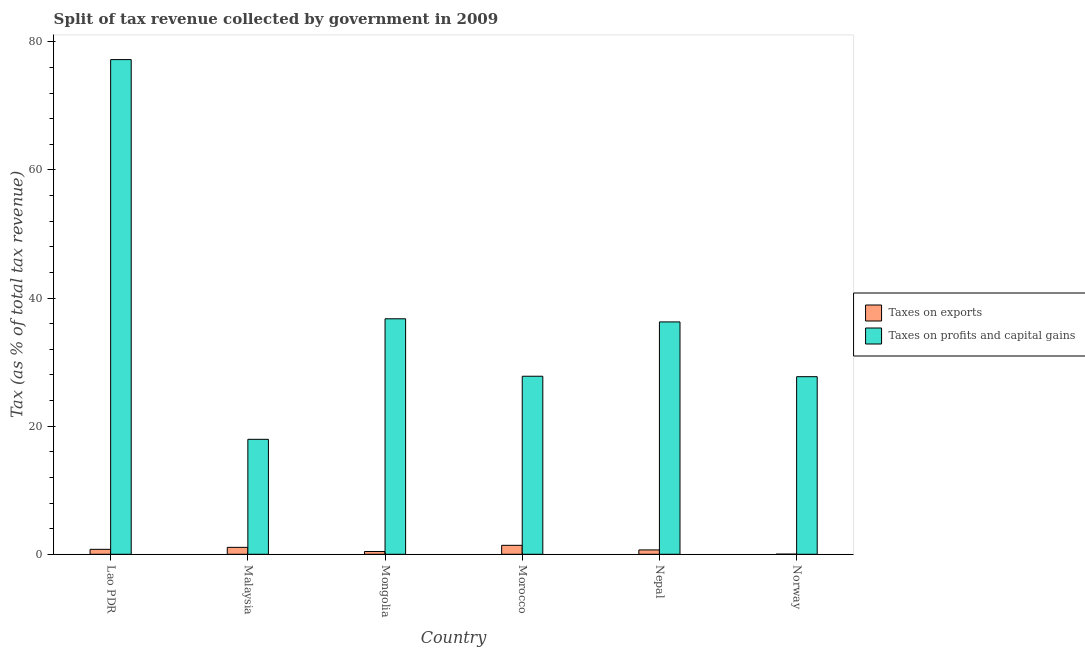How many groups of bars are there?
Your answer should be compact. 6. Are the number of bars on each tick of the X-axis equal?
Keep it short and to the point. Yes. How many bars are there on the 5th tick from the left?
Offer a terse response. 2. In how many cases, is the number of bars for a given country not equal to the number of legend labels?
Your answer should be compact. 0. What is the percentage of revenue obtained from taxes on profits and capital gains in Norway?
Keep it short and to the point. 27.72. Across all countries, what is the maximum percentage of revenue obtained from taxes on exports?
Offer a terse response. 1.4. Across all countries, what is the minimum percentage of revenue obtained from taxes on exports?
Your answer should be compact. 0.02. In which country was the percentage of revenue obtained from taxes on profits and capital gains maximum?
Offer a terse response. Lao PDR. In which country was the percentage of revenue obtained from taxes on profits and capital gains minimum?
Make the answer very short. Malaysia. What is the total percentage of revenue obtained from taxes on profits and capital gains in the graph?
Your response must be concise. 223.72. What is the difference between the percentage of revenue obtained from taxes on exports in Mongolia and that in Morocco?
Give a very brief answer. -0.96. What is the difference between the percentage of revenue obtained from taxes on profits and capital gains in Norway and the percentage of revenue obtained from taxes on exports in Mongolia?
Make the answer very short. 27.29. What is the average percentage of revenue obtained from taxes on profits and capital gains per country?
Offer a terse response. 37.29. What is the difference between the percentage of revenue obtained from taxes on profits and capital gains and percentage of revenue obtained from taxes on exports in Nepal?
Provide a succinct answer. 35.6. What is the ratio of the percentage of revenue obtained from taxes on profits and capital gains in Lao PDR to that in Morocco?
Make the answer very short. 2.78. What is the difference between the highest and the second highest percentage of revenue obtained from taxes on profits and capital gains?
Your answer should be compact. 40.46. What is the difference between the highest and the lowest percentage of revenue obtained from taxes on exports?
Your response must be concise. 1.38. In how many countries, is the percentage of revenue obtained from taxes on exports greater than the average percentage of revenue obtained from taxes on exports taken over all countries?
Offer a very short reply. 3. What does the 1st bar from the left in Malaysia represents?
Offer a terse response. Taxes on exports. What does the 1st bar from the right in Norway represents?
Your answer should be compact. Taxes on profits and capital gains. How many countries are there in the graph?
Ensure brevity in your answer.  6. Does the graph contain grids?
Provide a short and direct response. No. Where does the legend appear in the graph?
Provide a short and direct response. Center right. What is the title of the graph?
Offer a very short reply. Split of tax revenue collected by government in 2009. Does "Net savings(excluding particulate emission damage)" appear as one of the legend labels in the graph?
Provide a short and direct response. No. What is the label or title of the X-axis?
Your answer should be compact. Country. What is the label or title of the Y-axis?
Make the answer very short. Tax (as % of total tax revenue). What is the Tax (as % of total tax revenue) of Taxes on exports in Lao PDR?
Your response must be concise. 0.77. What is the Tax (as % of total tax revenue) in Taxes on profits and capital gains in Lao PDR?
Your answer should be compact. 77.22. What is the Tax (as % of total tax revenue) in Taxes on exports in Malaysia?
Offer a terse response. 1.08. What is the Tax (as % of total tax revenue) in Taxes on profits and capital gains in Malaysia?
Provide a short and direct response. 17.95. What is the Tax (as % of total tax revenue) in Taxes on exports in Mongolia?
Make the answer very short. 0.44. What is the Tax (as % of total tax revenue) in Taxes on profits and capital gains in Mongolia?
Give a very brief answer. 36.76. What is the Tax (as % of total tax revenue) in Taxes on exports in Morocco?
Give a very brief answer. 1.4. What is the Tax (as % of total tax revenue) of Taxes on profits and capital gains in Morocco?
Keep it short and to the point. 27.79. What is the Tax (as % of total tax revenue) of Taxes on exports in Nepal?
Give a very brief answer. 0.68. What is the Tax (as % of total tax revenue) of Taxes on profits and capital gains in Nepal?
Your response must be concise. 36.27. What is the Tax (as % of total tax revenue) in Taxes on exports in Norway?
Your answer should be compact. 0.02. What is the Tax (as % of total tax revenue) in Taxes on profits and capital gains in Norway?
Give a very brief answer. 27.72. Across all countries, what is the maximum Tax (as % of total tax revenue) in Taxes on exports?
Keep it short and to the point. 1.4. Across all countries, what is the maximum Tax (as % of total tax revenue) in Taxes on profits and capital gains?
Offer a terse response. 77.22. Across all countries, what is the minimum Tax (as % of total tax revenue) in Taxes on exports?
Offer a very short reply. 0.02. Across all countries, what is the minimum Tax (as % of total tax revenue) of Taxes on profits and capital gains?
Provide a succinct answer. 17.95. What is the total Tax (as % of total tax revenue) of Taxes on exports in the graph?
Give a very brief answer. 4.39. What is the total Tax (as % of total tax revenue) of Taxes on profits and capital gains in the graph?
Make the answer very short. 223.72. What is the difference between the Tax (as % of total tax revenue) in Taxes on exports in Lao PDR and that in Malaysia?
Ensure brevity in your answer.  -0.31. What is the difference between the Tax (as % of total tax revenue) in Taxes on profits and capital gains in Lao PDR and that in Malaysia?
Ensure brevity in your answer.  59.28. What is the difference between the Tax (as % of total tax revenue) in Taxes on exports in Lao PDR and that in Mongolia?
Offer a very short reply. 0.33. What is the difference between the Tax (as % of total tax revenue) of Taxes on profits and capital gains in Lao PDR and that in Mongolia?
Make the answer very short. 40.46. What is the difference between the Tax (as % of total tax revenue) in Taxes on exports in Lao PDR and that in Morocco?
Keep it short and to the point. -0.63. What is the difference between the Tax (as % of total tax revenue) in Taxes on profits and capital gains in Lao PDR and that in Morocco?
Your answer should be very brief. 49.43. What is the difference between the Tax (as % of total tax revenue) of Taxes on exports in Lao PDR and that in Nepal?
Offer a very short reply. 0.09. What is the difference between the Tax (as % of total tax revenue) of Taxes on profits and capital gains in Lao PDR and that in Nepal?
Your answer should be very brief. 40.95. What is the difference between the Tax (as % of total tax revenue) in Taxes on exports in Lao PDR and that in Norway?
Ensure brevity in your answer.  0.75. What is the difference between the Tax (as % of total tax revenue) of Taxes on profits and capital gains in Lao PDR and that in Norway?
Offer a terse response. 49.5. What is the difference between the Tax (as % of total tax revenue) of Taxes on exports in Malaysia and that in Mongolia?
Ensure brevity in your answer.  0.65. What is the difference between the Tax (as % of total tax revenue) in Taxes on profits and capital gains in Malaysia and that in Mongolia?
Give a very brief answer. -18.82. What is the difference between the Tax (as % of total tax revenue) in Taxes on exports in Malaysia and that in Morocco?
Give a very brief answer. -0.32. What is the difference between the Tax (as % of total tax revenue) of Taxes on profits and capital gains in Malaysia and that in Morocco?
Your answer should be compact. -9.85. What is the difference between the Tax (as % of total tax revenue) in Taxes on exports in Malaysia and that in Nepal?
Offer a terse response. 0.4. What is the difference between the Tax (as % of total tax revenue) of Taxes on profits and capital gains in Malaysia and that in Nepal?
Offer a very short reply. -18.33. What is the difference between the Tax (as % of total tax revenue) in Taxes on exports in Malaysia and that in Norway?
Offer a terse response. 1.06. What is the difference between the Tax (as % of total tax revenue) in Taxes on profits and capital gains in Malaysia and that in Norway?
Give a very brief answer. -9.78. What is the difference between the Tax (as % of total tax revenue) in Taxes on exports in Mongolia and that in Morocco?
Provide a short and direct response. -0.96. What is the difference between the Tax (as % of total tax revenue) in Taxes on profits and capital gains in Mongolia and that in Morocco?
Your answer should be very brief. 8.97. What is the difference between the Tax (as % of total tax revenue) in Taxes on exports in Mongolia and that in Nepal?
Keep it short and to the point. -0.24. What is the difference between the Tax (as % of total tax revenue) in Taxes on profits and capital gains in Mongolia and that in Nepal?
Keep it short and to the point. 0.49. What is the difference between the Tax (as % of total tax revenue) in Taxes on exports in Mongolia and that in Norway?
Your answer should be compact. 0.42. What is the difference between the Tax (as % of total tax revenue) in Taxes on profits and capital gains in Mongolia and that in Norway?
Make the answer very short. 9.04. What is the difference between the Tax (as % of total tax revenue) of Taxes on exports in Morocco and that in Nepal?
Make the answer very short. 0.72. What is the difference between the Tax (as % of total tax revenue) in Taxes on profits and capital gains in Morocco and that in Nepal?
Offer a very short reply. -8.48. What is the difference between the Tax (as % of total tax revenue) in Taxes on exports in Morocco and that in Norway?
Offer a very short reply. 1.38. What is the difference between the Tax (as % of total tax revenue) of Taxes on profits and capital gains in Morocco and that in Norway?
Make the answer very short. 0.07. What is the difference between the Tax (as % of total tax revenue) of Taxes on exports in Nepal and that in Norway?
Give a very brief answer. 0.66. What is the difference between the Tax (as % of total tax revenue) in Taxes on profits and capital gains in Nepal and that in Norway?
Keep it short and to the point. 8.55. What is the difference between the Tax (as % of total tax revenue) in Taxes on exports in Lao PDR and the Tax (as % of total tax revenue) in Taxes on profits and capital gains in Malaysia?
Ensure brevity in your answer.  -17.17. What is the difference between the Tax (as % of total tax revenue) in Taxes on exports in Lao PDR and the Tax (as % of total tax revenue) in Taxes on profits and capital gains in Mongolia?
Your answer should be very brief. -35.99. What is the difference between the Tax (as % of total tax revenue) in Taxes on exports in Lao PDR and the Tax (as % of total tax revenue) in Taxes on profits and capital gains in Morocco?
Keep it short and to the point. -27.02. What is the difference between the Tax (as % of total tax revenue) in Taxes on exports in Lao PDR and the Tax (as % of total tax revenue) in Taxes on profits and capital gains in Nepal?
Your answer should be compact. -35.5. What is the difference between the Tax (as % of total tax revenue) of Taxes on exports in Lao PDR and the Tax (as % of total tax revenue) of Taxes on profits and capital gains in Norway?
Provide a short and direct response. -26.95. What is the difference between the Tax (as % of total tax revenue) of Taxes on exports in Malaysia and the Tax (as % of total tax revenue) of Taxes on profits and capital gains in Mongolia?
Offer a very short reply. -35.68. What is the difference between the Tax (as % of total tax revenue) of Taxes on exports in Malaysia and the Tax (as % of total tax revenue) of Taxes on profits and capital gains in Morocco?
Provide a succinct answer. -26.71. What is the difference between the Tax (as % of total tax revenue) of Taxes on exports in Malaysia and the Tax (as % of total tax revenue) of Taxes on profits and capital gains in Nepal?
Make the answer very short. -35.19. What is the difference between the Tax (as % of total tax revenue) in Taxes on exports in Malaysia and the Tax (as % of total tax revenue) in Taxes on profits and capital gains in Norway?
Your answer should be compact. -26.64. What is the difference between the Tax (as % of total tax revenue) in Taxes on exports in Mongolia and the Tax (as % of total tax revenue) in Taxes on profits and capital gains in Morocco?
Your answer should be compact. -27.36. What is the difference between the Tax (as % of total tax revenue) in Taxes on exports in Mongolia and the Tax (as % of total tax revenue) in Taxes on profits and capital gains in Nepal?
Your answer should be compact. -35.84. What is the difference between the Tax (as % of total tax revenue) in Taxes on exports in Mongolia and the Tax (as % of total tax revenue) in Taxes on profits and capital gains in Norway?
Your answer should be compact. -27.29. What is the difference between the Tax (as % of total tax revenue) of Taxes on exports in Morocco and the Tax (as % of total tax revenue) of Taxes on profits and capital gains in Nepal?
Your answer should be very brief. -34.87. What is the difference between the Tax (as % of total tax revenue) of Taxes on exports in Morocco and the Tax (as % of total tax revenue) of Taxes on profits and capital gains in Norway?
Provide a short and direct response. -26.32. What is the difference between the Tax (as % of total tax revenue) in Taxes on exports in Nepal and the Tax (as % of total tax revenue) in Taxes on profits and capital gains in Norway?
Provide a short and direct response. -27.05. What is the average Tax (as % of total tax revenue) in Taxes on exports per country?
Provide a succinct answer. 0.73. What is the average Tax (as % of total tax revenue) of Taxes on profits and capital gains per country?
Give a very brief answer. 37.29. What is the difference between the Tax (as % of total tax revenue) of Taxes on exports and Tax (as % of total tax revenue) of Taxes on profits and capital gains in Lao PDR?
Provide a short and direct response. -76.45. What is the difference between the Tax (as % of total tax revenue) in Taxes on exports and Tax (as % of total tax revenue) in Taxes on profits and capital gains in Malaysia?
Offer a very short reply. -16.86. What is the difference between the Tax (as % of total tax revenue) in Taxes on exports and Tax (as % of total tax revenue) in Taxes on profits and capital gains in Mongolia?
Offer a very short reply. -36.33. What is the difference between the Tax (as % of total tax revenue) of Taxes on exports and Tax (as % of total tax revenue) of Taxes on profits and capital gains in Morocco?
Provide a short and direct response. -26.39. What is the difference between the Tax (as % of total tax revenue) of Taxes on exports and Tax (as % of total tax revenue) of Taxes on profits and capital gains in Nepal?
Make the answer very short. -35.6. What is the difference between the Tax (as % of total tax revenue) in Taxes on exports and Tax (as % of total tax revenue) in Taxes on profits and capital gains in Norway?
Provide a succinct answer. -27.7. What is the ratio of the Tax (as % of total tax revenue) in Taxes on exports in Lao PDR to that in Malaysia?
Keep it short and to the point. 0.71. What is the ratio of the Tax (as % of total tax revenue) of Taxes on profits and capital gains in Lao PDR to that in Malaysia?
Your response must be concise. 4.3. What is the ratio of the Tax (as % of total tax revenue) of Taxes on exports in Lao PDR to that in Mongolia?
Offer a very short reply. 1.77. What is the ratio of the Tax (as % of total tax revenue) in Taxes on profits and capital gains in Lao PDR to that in Mongolia?
Ensure brevity in your answer.  2.1. What is the ratio of the Tax (as % of total tax revenue) in Taxes on exports in Lao PDR to that in Morocco?
Give a very brief answer. 0.55. What is the ratio of the Tax (as % of total tax revenue) of Taxes on profits and capital gains in Lao PDR to that in Morocco?
Ensure brevity in your answer.  2.78. What is the ratio of the Tax (as % of total tax revenue) in Taxes on exports in Lao PDR to that in Nepal?
Ensure brevity in your answer.  1.14. What is the ratio of the Tax (as % of total tax revenue) in Taxes on profits and capital gains in Lao PDR to that in Nepal?
Give a very brief answer. 2.13. What is the ratio of the Tax (as % of total tax revenue) in Taxes on exports in Lao PDR to that in Norway?
Provide a short and direct response. 37.14. What is the ratio of the Tax (as % of total tax revenue) of Taxes on profits and capital gains in Lao PDR to that in Norway?
Give a very brief answer. 2.79. What is the ratio of the Tax (as % of total tax revenue) in Taxes on exports in Malaysia to that in Mongolia?
Make the answer very short. 2.48. What is the ratio of the Tax (as % of total tax revenue) of Taxes on profits and capital gains in Malaysia to that in Mongolia?
Offer a terse response. 0.49. What is the ratio of the Tax (as % of total tax revenue) of Taxes on exports in Malaysia to that in Morocco?
Make the answer very short. 0.77. What is the ratio of the Tax (as % of total tax revenue) in Taxes on profits and capital gains in Malaysia to that in Morocco?
Make the answer very short. 0.65. What is the ratio of the Tax (as % of total tax revenue) in Taxes on exports in Malaysia to that in Nepal?
Offer a terse response. 1.6. What is the ratio of the Tax (as % of total tax revenue) in Taxes on profits and capital gains in Malaysia to that in Nepal?
Your answer should be very brief. 0.49. What is the ratio of the Tax (as % of total tax revenue) of Taxes on exports in Malaysia to that in Norway?
Your answer should be very brief. 52.12. What is the ratio of the Tax (as % of total tax revenue) in Taxes on profits and capital gains in Malaysia to that in Norway?
Your answer should be compact. 0.65. What is the ratio of the Tax (as % of total tax revenue) in Taxes on exports in Mongolia to that in Morocco?
Make the answer very short. 0.31. What is the ratio of the Tax (as % of total tax revenue) of Taxes on profits and capital gains in Mongolia to that in Morocco?
Give a very brief answer. 1.32. What is the ratio of the Tax (as % of total tax revenue) of Taxes on exports in Mongolia to that in Nepal?
Make the answer very short. 0.64. What is the ratio of the Tax (as % of total tax revenue) in Taxes on profits and capital gains in Mongolia to that in Nepal?
Keep it short and to the point. 1.01. What is the ratio of the Tax (as % of total tax revenue) in Taxes on exports in Mongolia to that in Norway?
Your answer should be compact. 21.02. What is the ratio of the Tax (as % of total tax revenue) in Taxes on profits and capital gains in Mongolia to that in Norway?
Your answer should be very brief. 1.33. What is the ratio of the Tax (as % of total tax revenue) in Taxes on exports in Morocco to that in Nepal?
Make the answer very short. 2.06. What is the ratio of the Tax (as % of total tax revenue) in Taxes on profits and capital gains in Morocco to that in Nepal?
Your answer should be very brief. 0.77. What is the ratio of the Tax (as % of total tax revenue) of Taxes on exports in Morocco to that in Norway?
Your answer should be very brief. 67.4. What is the ratio of the Tax (as % of total tax revenue) of Taxes on exports in Nepal to that in Norway?
Your answer should be compact. 32.68. What is the ratio of the Tax (as % of total tax revenue) of Taxes on profits and capital gains in Nepal to that in Norway?
Offer a very short reply. 1.31. What is the difference between the highest and the second highest Tax (as % of total tax revenue) in Taxes on exports?
Your answer should be compact. 0.32. What is the difference between the highest and the second highest Tax (as % of total tax revenue) in Taxes on profits and capital gains?
Provide a succinct answer. 40.46. What is the difference between the highest and the lowest Tax (as % of total tax revenue) in Taxes on exports?
Your answer should be compact. 1.38. What is the difference between the highest and the lowest Tax (as % of total tax revenue) of Taxes on profits and capital gains?
Your answer should be very brief. 59.28. 